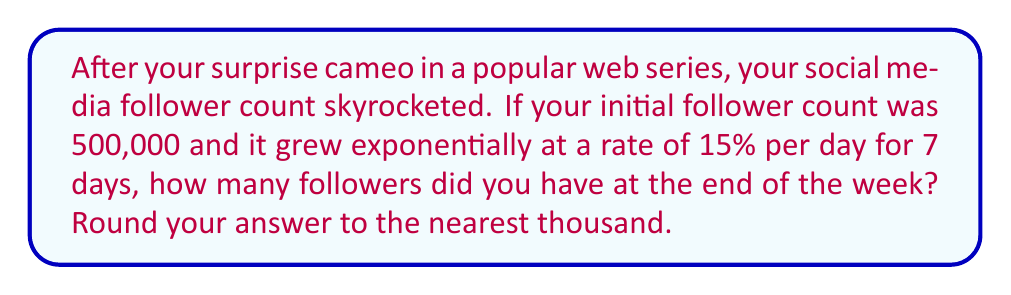Can you solve this math problem? Let's approach this step-by-step using an exponential growth model:

1) The exponential growth formula is:
   $A = P(1 + r)^t$
   Where:
   $A$ = Final amount
   $P$ = Initial principal (initial follower count)
   $r$ = Growth rate (as a decimal)
   $t$ = Time period

2) We know:
   $P = 500,000$ (initial followers)
   $r = 15\% = 0.15$ (growth rate per day)
   $t = 7$ (days)

3) Let's substitute these values into our formula:
   $A = 500,000(1 + 0.15)^7$

4) Simplify inside the parentheses:
   $A = 500,000(1.15)^7$

5) Calculate $(1.15)^7$:
   $(1.15)^7 \approx 2.6600$

6) Multiply:
   $A = 500,000 \times 2.6600 = 1,330,000$

7) Rounding to the nearest thousand:
   $A \approx 1,330,000$
Answer: 1,330,000 followers 